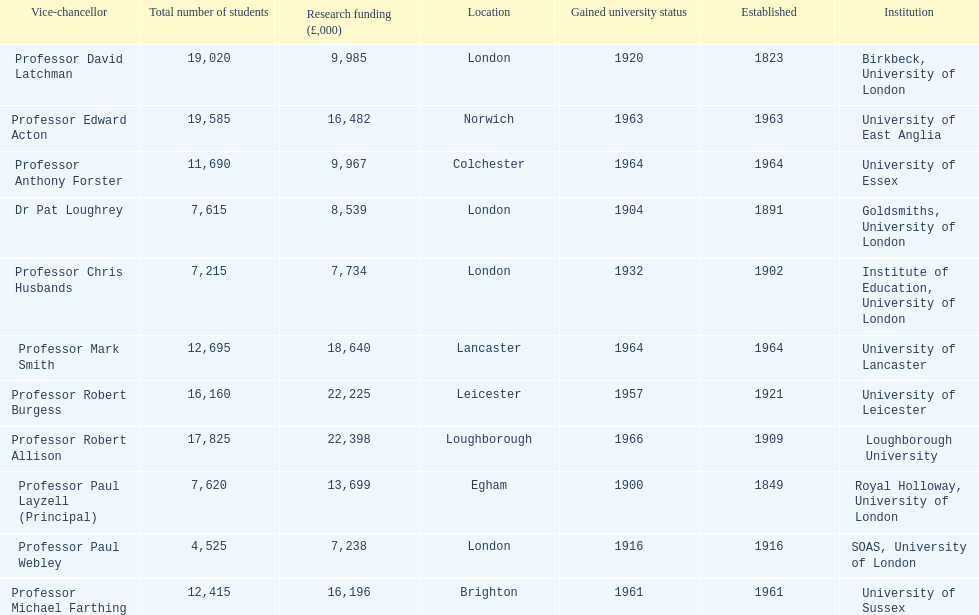How many of the institutions are located in london? 4. 